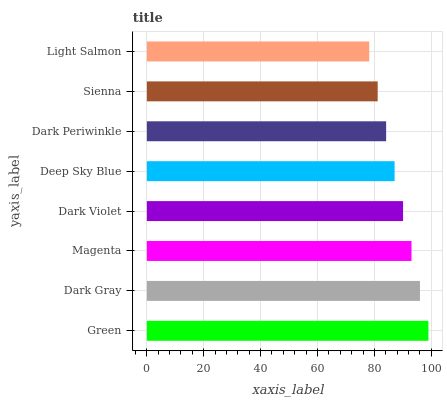Is Light Salmon the minimum?
Answer yes or no. Yes. Is Green the maximum?
Answer yes or no. Yes. Is Dark Gray the minimum?
Answer yes or no. No. Is Dark Gray the maximum?
Answer yes or no. No. Is Green greater than Dark Gray?
Answer yes or no. Yes. Is Dark Gray less than Green?
Answer yes or no. Yes. Is Dark Gray greater than Green?
Answer yes or no. No. Is Green less than Dark Gray?
Answer yes or no. No. Is Dark Violet the high median?
Answer yes or no. Yes. Is Deep Sky Blue the low median?
Answer yes or no. Yes. Is Sienna the high median?
Answer yes or no. No. Is Light Salmon the low median?
Answer yes or no. No. 